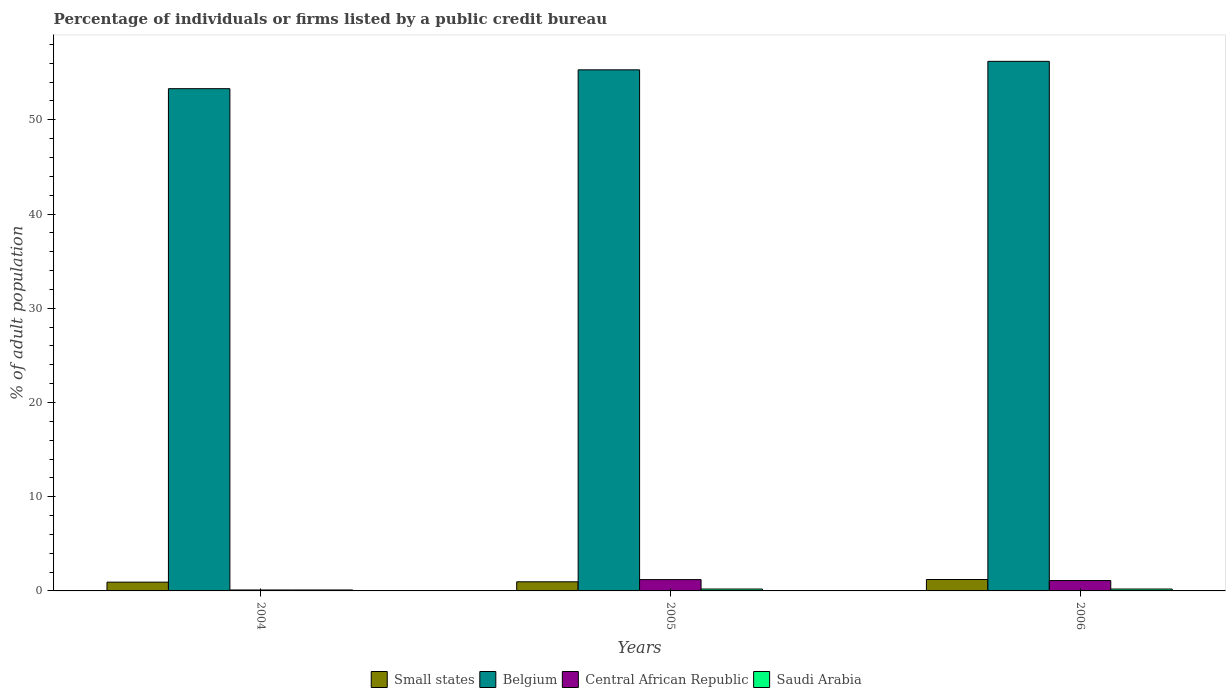How many groups of bars are there?
Provide a short and direct response. 3. What is the label of the 1st group of bars from the left?
Offer a very short reply. 2004. In how many cases, is the number of bars for a given year not equal to the number of legend labels?
Your response must be concise. 0. What is the percentage of population listed by a public credit bureau in Central African Republic in 2006?
Give a very brief answer. 1.1. In which year was the percentage of population listed by a public credit bureau in Small states maximum?
Ensure brevity in your answer.  2006. In which year was the percentage of population listed by a public credit bureau in Small states minimum?
Provide a short and direct response. 2004. What is the total percentage of population listed by a public credit bureau in Central African Republic in the graph?
Keep it short and to the point. 2.4. What is the difference between the percentage of population listed by a public credit bureau in Belgium in 2004 and that in 2006?
Keep it short and to the point. -2.9. What is the difference between the percentage of population listed by a public credit bureau in Saudi Arabia in 2006 and the percentage of population listed by a public credit bureau in Belgium in 2004?
Your response must be concise. -53.1. What is the average percentage of population listed by a public credit bureau in Belgium per year?
Ensure brevity in your answer.  54.93. In the year 2006, what is the difference between the percentage of population listed by a public credit bureau in Small states and percentage of population listed by a public credit bureau in Belgium?
Your answer should be very brief. -54.99. What is the ratio of the percentage of population listed by a public credit bureau in Small states in 2005 to that in 2006?
Your response must be concise. 0.8. Is the percentage of population listed by a public credit bureau in Saudi Arabia in 2004 less than that in 2006?
Keep it short and to the point. Yes. What is the difference between the highest and the second highest percentage of population listed by a public credit bureau in Central African Republic?
Keep it short and to the point. 0.1. What is the difference between the highest and the lowest percentage of population listed by a public credit bureau in Small states?
Offer a very short reply. 0.28. In how many years, is the percentage of population listed by a public credit bureau in Small states greater than the average percentage of population listed by a public credit bureau in Small states taken over all years?
Offer a very short reply. 1. Is it the case that in every year, the sum of the percentage of population listed by a public credit bureau in Central African Republic and percentage of population listed by a public credit bureau in Small states is greater than the sum of percentage of population listed by a public credit bureau in Belgium and percentage of population listed by a public credit bureau in Saudi Arabia?
Ensure brevity in your answer.  No. What does the 1st bar from the left in 2005 represents?
Offer a terse response. Small states. What does the 4th bar from the right in 2006 represents?
Offer a terse response. Small states. Is it the case that in every year, the sum of the percentage of population listed by a public credit bureau in Small states and percentage of population listed by a public credit bureau in Central African Republic is greater than the percentage of population listed by a public credit bureau in Belgium?
Ensure brevity in your answer.  No. How many bars are there?
Your answer should be very brief. 12. Are all the bars in the graph horizontal?
Provide a short and direct response. No. How many years are there in the graph?
Provide a succinct answer. 3. Does the graph contain any zero values?
Ensure brevity in your answer.  No. Where does the legend appear in the graph?
Your answer should be compact. Bottom center. How many legend labels are there?
Provide a succinct answer. 4. What is the title of the graph?
Your answer should be very brief. Percentage of individuals or firms listed by a public credit bureau. What is the label or title of the Y-axis?
Provide a succinct answer. % of adult population. What is the % of adult population in Small states in 2004?
Ensure brevity in your answer.  0.93. What is the % of adult population in Belgium in 2004?
Make the answer very short. 53.3. What is the % of adult population of Central African Republic in 2004?
Make the answer very short. 0.1. What is the % of adult population of Small states in 2005?
Keep it short and to the point. 0.97. What is the % of adult population of Belgium in 2005?
Keep it short and to the point. 55.3. What is the % of adult population of Central African Republic in 2005?
Your answer should be compact. 1.2. What is the % of adult population of Small states in 2006?
Offer a terse response. 1.21. What is the % of adult population of Belgium in 2006?
Offer a very short reply. 56.2. Across all years, what is the maximum % of adult population of Small states?
Make the answer very short. 1.21. Across all years, what is the maximum % of adult population of Belgium?
Ensure brevity in your answer.  56.2. Across all years, what is the minimum % of adult population in Small states?
Offer a very short reply. 0.93. Across all years, what is the minimum % of adult population in Belgium?
Offer a terse response. 53.3. What is the total % of adult population of Small states in the graph?
Your answer should be very brief. 3.11. What is the total % of adult population in Belgium in the graph?
Your answer should be compact. 164.8. What is the total % of adult population of Saudi Arabia in the graph?
Make the answer very short. 0.5. What is the difference between the % of adult population of Small states in 2004 and that in 2005?
Your answer should be compact. -0.04. What is the difference between the % of adult population of Central African Republic in 2004 and that in 2005?
Offer a very short reply. -1.1. What is the difference between the % of adult population of Small states in 2004 and that in 2006?
Keep it short and to the point. -0.28. What is the difference between the % of adult population of Belgium in 2004 and that in 2006?
Offer a very short reply. -2.9. What is the difference between the % of adult population of Central African Republic in 2004 and that in 2006?
Offer a terse response. -1. What is the difference between the % of adult population of Saudi Arabia in 2004 and that in 2006?
Make the answer very short. -0.1. What is the difference between the % of adult population in Small states in 2005 and that in 2006?
Your answer should be compact. -0.24. What is the difference between the % of adult population of Small states in 2004 and the % of adult population of Belgium in 2005?
Provide a succinct answer. -54.37. What is the difference between the % of adult population of Small states in 2004 and the % of adult population of Central African Republic in 2005?
Give a very brief answer. -0.27. What is the difference between the % of adult population of Small states in 2004 and the % of adult population of Saudi Arabia in 2005?
Your answer should be compact. 0.73. What is the difference between the % of adult population of Belgium in 2004 and the % of adult population of Central African Republic in 2005?
Keep it short and to the point. 52.1. What is the difference between the % of adult population in Belgium in 2004 and the % of adult population in Saudi Arabia in 2005?
Provide a succinct answer. 53.1. What is the difference between the % of adult population in Central African Republic in 2004 and the % of adult population in Saudi Arabia in 2005?
Give a very brief answer. -0.1. What is the difference between the % of adult population of Small states in 2004 and the % of adult population of Belgium in 2006?
Provide a short and direct response. -55.27. What is the difference between the % of adult population of Small states in 2004 and the % of adult population of Central African Republic in 2006?
Provide a short and direct response. -0.17. What is the difference between the % of adult population in Small states in 2004 and the % of adult population in Saudi Arabia in 2006?
Your answer should be compact. 0.73. What is the difference between the % of adult population in Belgium in 2004 and the % of adult population in Central African Republic in 2006?
Offer a terse response. 52.2. What is the difference between the % of adult population of Belgium in 2004 and the % of adult population of Saudi Arabia in 2006?
Provide a succinct answer. 53.1. What is the difference between the % of adult population in Central African Republic in 2004 and the % of adult population in Saudi Arabia in 2006?
Your answer should be very brief. -0.1. What is the difference between the % of adult population of Small states in 2005 and the % of adult population of Belgium in 2006?
Your response must be concise. -55.23. What is the difference between the % of adult population of Small states in 2005 and the % of adult population of Central African Republic in 2006?
Ensure brevity in your answer.  -0.13. What is the difference between the % of adult population in Small states in 2005 and the % of adult population in Saudi Arabia in 2006?
Your answer should be compact. 0.77. What is the difference between the % of adult population in Belgium in 2005 and the % of adult population in Central African Republic in 2006?
Provide a succinct answer. 54.2. What is the difference between the % of adult population of Belgium in 2005 and the % of adult population of Saudi Arabia in 2006?
Make the answer very short. 55.1. What is the average % of adult population in Small states per year?
Ensure brevity in your answer.  1.04. What is the average % of adult population of Belgium per year?
Offer a very short reply. 54.93. In the year 2004, what is the difference between the % of adult population in Small states and % of adult population in Belgium?
Keep it short and to the point. -52.37. In the year 2004, what is the difference between the % of adult population of Small states and % of adult population of Central African Republic?
Give a very brief answer. 0.83. In the year 2004, what is the difference between the % of adult population in Small states and % of adult population in Saudi Arabia?
Give a very brief answer. 0.83. In the year 2004, what is the difference between the % of adult population in Belgium and % of adult population in Central African Republic?
Your answer should be compact. 53.2. In the year 2004, what is the difference between the % of adult population in Belgium and % of adult population in Saudi Arabia?
Make the answer very short. 53.2. In the year 2005, what is the difference between the % of adult population in Small states and % of adult population in Belgium?
Provide a short and direct response. -54.33. In the year 2005, what is the difference between the % of adult population in Small states and % of adult population in Central African Republic?
Provide a short and direct response. -0.23. In the year 2005, what is the difference between the % of adult population of Small states and % of adult population of Saudi Arabia?
Provide a succinct answer. 0.77. In the year 2005, what is the difference between the % of adult population in Belgium and % of adult population in Central African Republic?
Provide a short and direct response. 54.1. In the year 2005, what is the difference between the % of adult population of Belgium and % of adult population of Saudi Arabia?
Provide a short and direct response. 55.1. In the year 2005, what is the difference between the % of adult population of Central African Republic and % of adult population of Saudi Arabia?
Keep it short and to the point. 1. In the year 2006, what is the difference between the % of adult population in Small states and % of adult population in Belgium?
Your response must be concise. -54.99. In the year 2006, what is the difference between the % of adult population in Small states and % of adult population in Central African Republic?
Ensure brevity in your answer.  0.11. In the year 2006, what is the difference between the % of adult population in Small states and % of adult population in Saudi Arabia?
Your response must be concise. 1.01. In the year 2006, what is the difference between the % of adult population of Belgium and % of adult population of Central African Republic?
Your answer should be very brief. 55.1. In the year 2006, what is the difference between the % of adult population in Belgium and % of adult population in Saudi Arabia?
Your answer should be very brief. 56. What is the ratio of the % of adult population of Small states in 2004 to that in 2005?
Your answer should be very brief. 0.96. What is the ratio of the % of adult population in Belgium in 2004 to that in 2005?
Your response must be concise. 0.96. What is the ratio of the % of adult population of Central African Republic in 2004 to that in 2005?
Offer a terse response. 0.08. What is the ratio of the % of adult population of Small states in 2004 to that in 2006?
Ensure brevity in your answer.  0.77. What is the ratio of the % of adult population of Belgium in 2004 to that in 2006?
Offer a very short reply. 0.95. What is the ratio of the % of adult population in Central African Republic in 2004 to that in 2006?
Provide a short and direct response. 0.09. What is the ratio of the % of adult population in Small states in 2005 to that in 2006?
Offer a very short reply. 0.8. What is the difference between the highest and the second highest % of adult population of Small states?
Make the answer very short. 0.24. What is the difference between the highest and the second highest % of adult population of Saudi Arabia?
Your response must be concise. 0. What is the difference between the highest and the lowest % of adult population of Small states?
Ensure brevity in your answer.  0.28. 